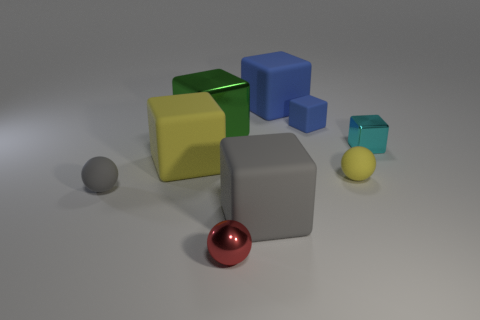There is a small block that is left of the tiny cyan block; does it have the same color as the large metal cube?
Offer a very short reply. No. The gray object to the left of the yellow matte object that is to the left of the small blue cube is what shape?
Make the answer very short. Sphere. Are there any rubber spheres that have the same size as the cyan cube?
Give a very brief answer. Yes. Are there fewer green blocks than tiny things?
Your answer should be very brief. Yes. The metal thing that is on the right side of the gray thing to the right of the yellow thing left of the small red shiny thing is what shape?
Provide a succinct answer. Cube. How many objects are tiny spheres to the left of the big blue rubber cube or big rubber blocks that are behind the cyan metal cube?
Ensure brevity in your answer.  3. There is a large yellow object; are there any large metallic cubes behind it?
Provide a short and direct response. Yes. What number of things are matte blocks in front of the small rubber block or cyan objects?
Offer a very short reply. 3. What number of purple objects are matte cubes or small metal objects?
Offer a terse response. 0. What number of other objects are the same color as the small metal sphere?
Provide a succinct answer. 0. 